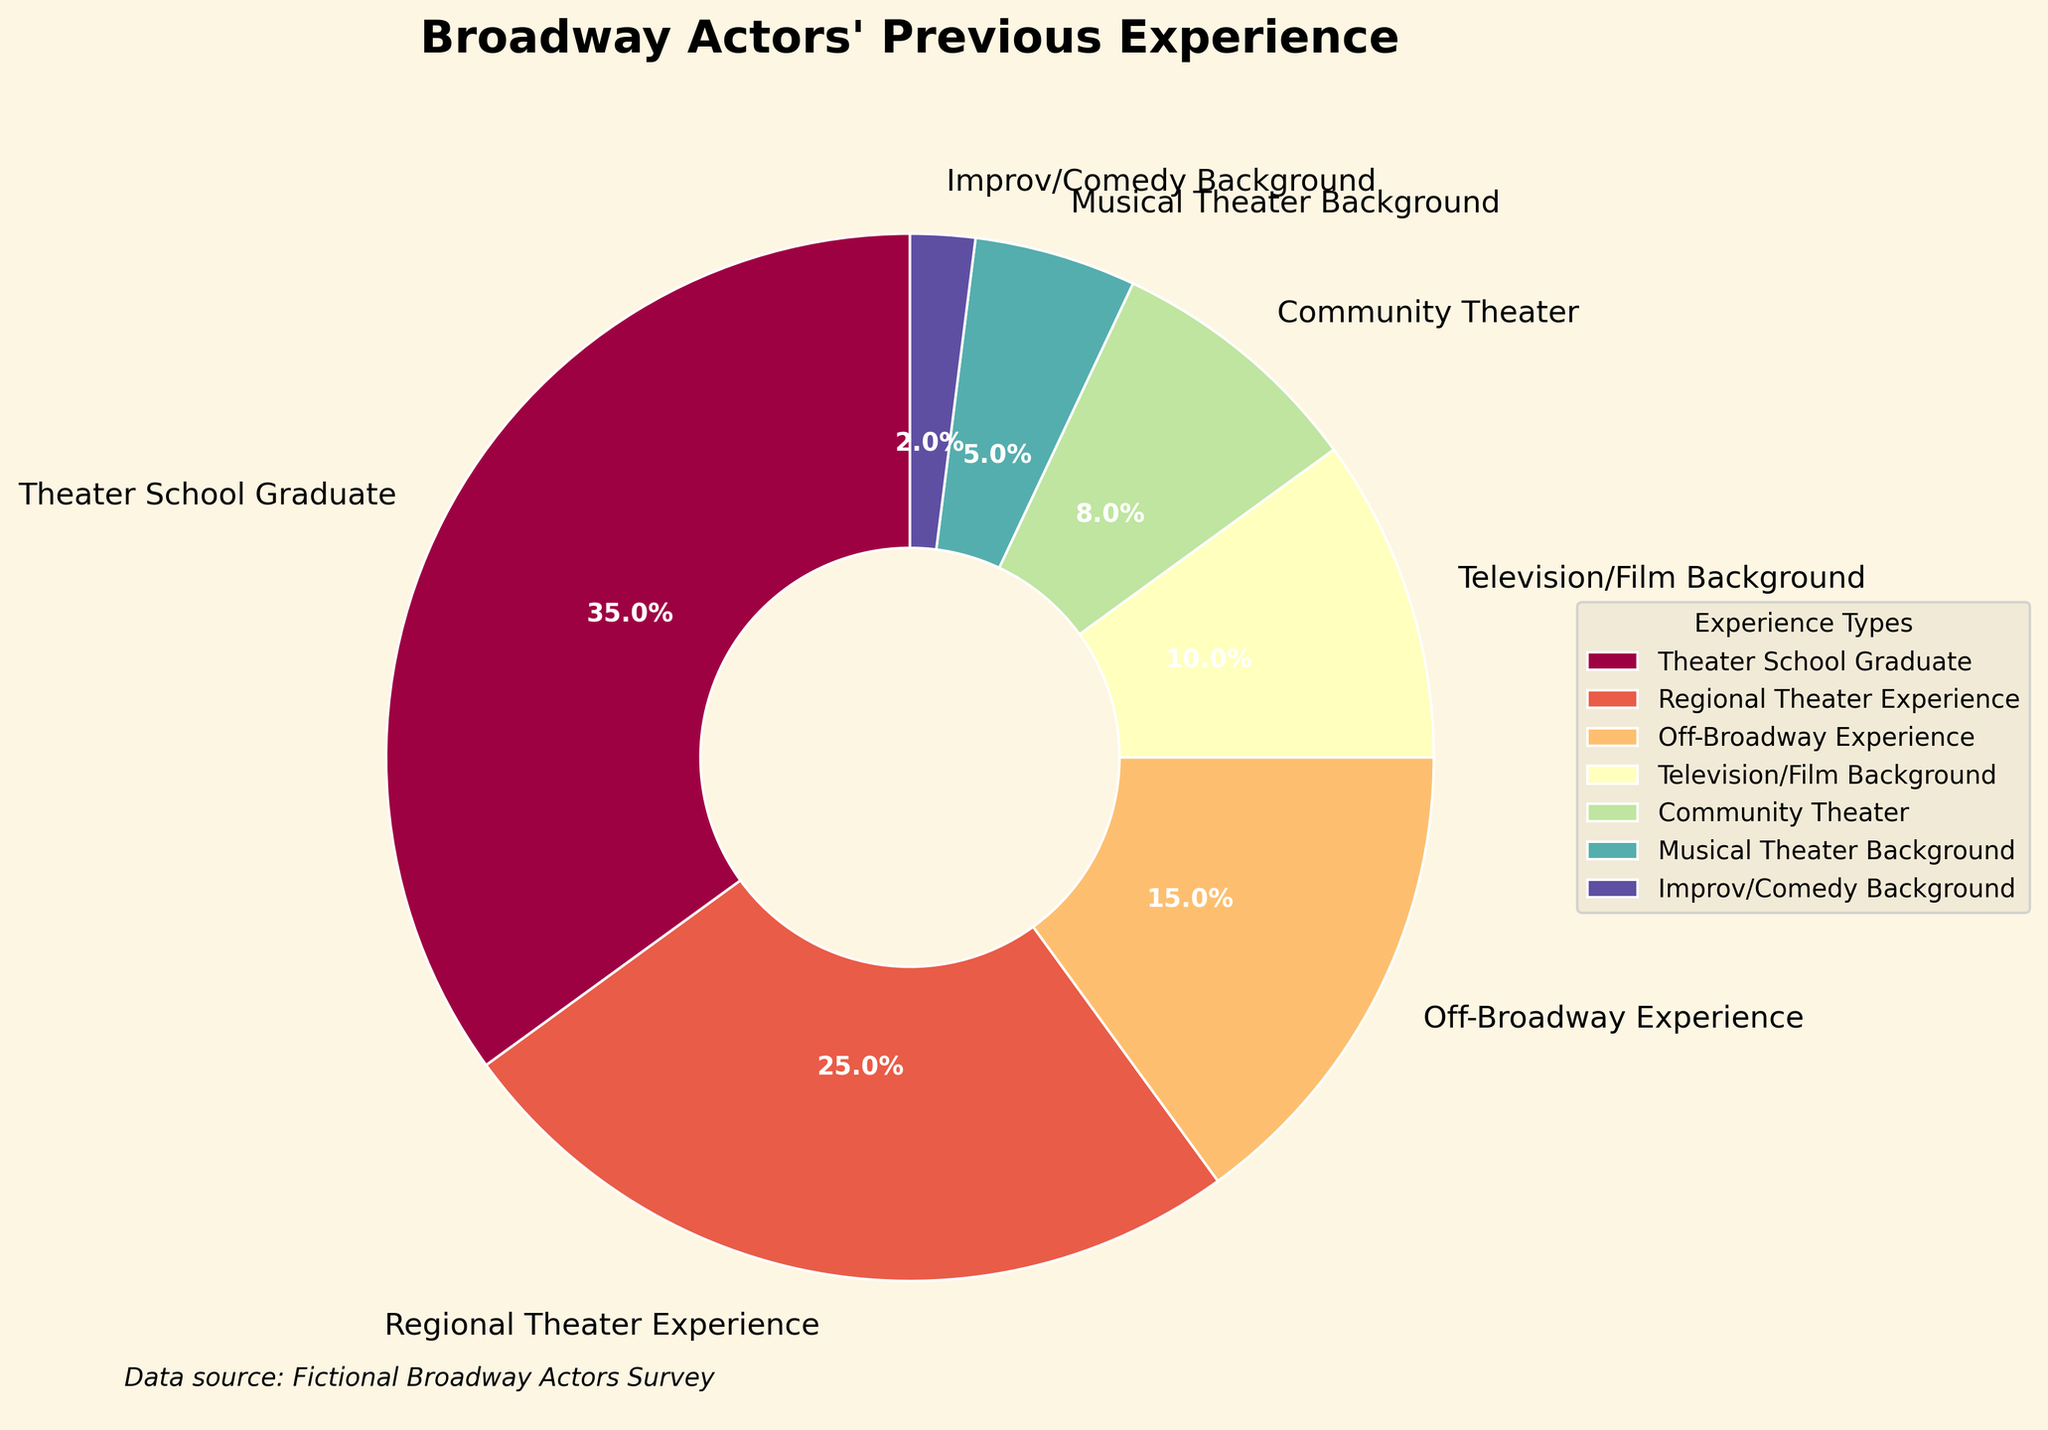Which category has the highest percentage of Broadway actors? The pie chart shows that the largest slice corresponds to "Theater School Graduate," with a percentage of 35%
Answer: Theater School Graduate Which two categories combined make up more than 50% of the Broadway actors' previous experience? Adding the percentages of "Theater School Graduate" (35%) and "Regional Theater Experience" (25%) gives a total of 60%, which is more than half.
Answer: Theater School Graduate and Regional Theater Experience How much more common is it for Broadway actors to have a Television/Film background compared to an Improv/Comedy background? The Television/Film Background slice is 10%, while the Improv/Comedy Background slice is 2%. The difference is 10% - 2% = 8%.
Answer: 8% Which category has the smallest representation among Broadway actors' previous experiences? The smallest slice on the chart is labeled "Improv/Comedy Background," with a percentage of 2%
Answer: Improv/Comedy Background What percentage of Broadway actors have Off-Broadway or Community Theater experience? Adding the percentages of "Off-Broadway Experience" (15%) and "Community Theater" (8%) gives 15% + 8% = 23%
Answer: 23% Which category is more common: Musical Theater Background or Community Theater? The slice for "Community Theater" is 8%, while the slice for "Musical Theater Background" is 5%. Therefore, Community Theater is more common.
Answer: Community Theater If you were to combine the percentages of actors with Regional Theater and Off-Broadway Experience, what would be the total percentage? Adding the percentages of "Regional Theater Experience" (25%) and "Off-Broadway Experience" (15%) results in 25% + 15% = 40%
Answer: 40% Which color is associated with the largest category on the pie chart? The largest slice, representing "Theater School Graduate" (35%), is colored in a light spectrum shade (depends on the color map figsize).
Answer: A light spectrum shade (specific color might vary) 